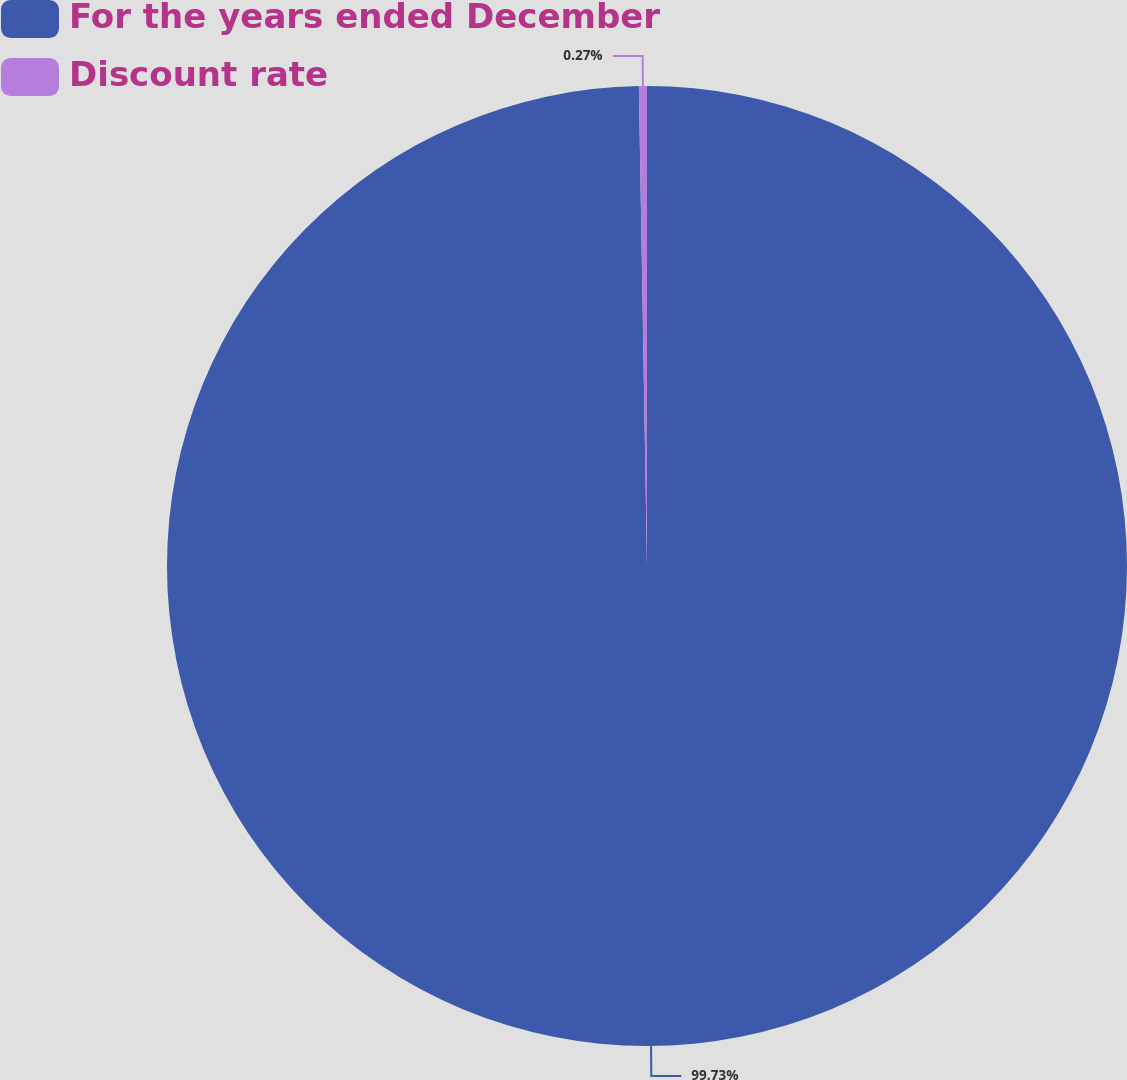<chart> <loc_0><loc_0><loc_500><loc_500><pie_chart><fcel>For the years ended December<fcel>Discount rate<nl><fcel>99.73%<fcel>0.27%<nl></chart> 